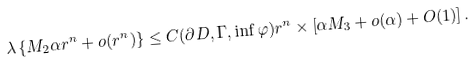Convert formula to latex. <formula><loc_0><loc_0><loc_500><loc_500>\lambda \left \{ M _ { 2 } \alpha r ^ { n } + o ( r ^ { n } ) \right \} \leq C ( \partial D , \Gamma , \inf \varphi ) r ^ { n } \times \left [ \alpha M _ { 3 } + o ( \alpha ) + O ( 1 ) \right ] .</formula> 